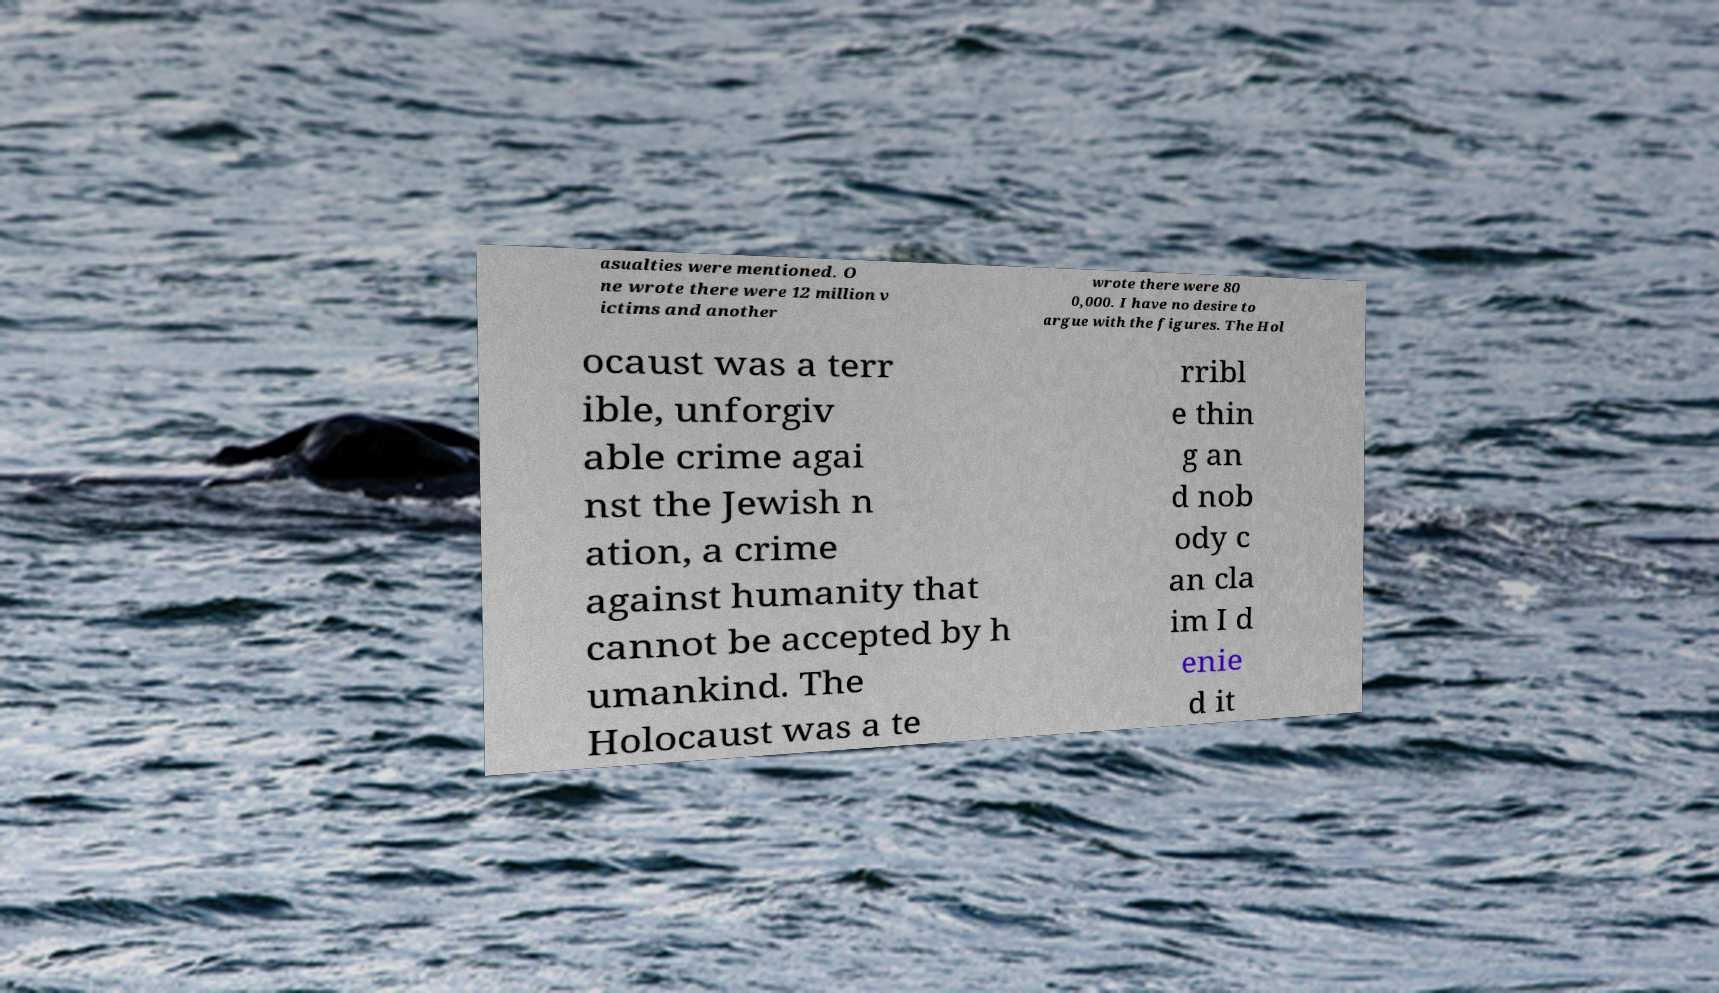For documentation purposes, I need the text within this image transcribed. Could you provide that? asualties were mentioned. O ne wrote there were 12 million v ictims and another wrote there were 80 0,000. I have no desire to argue with the figures. The Hol ocaust was a terr ible, unforgiv able crime agai nst the Jewish n ation, a crime against humanity that cannot be accepted by h umankind. The Holocaust was a te rribl e thin g an d nob ody c an cla im I d enie d it 